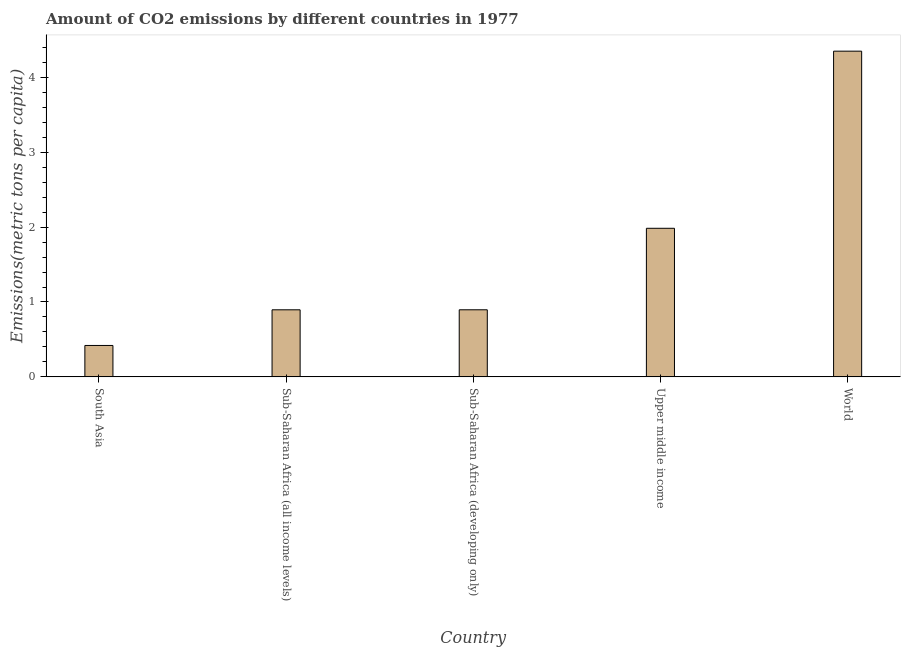Does the graph contain any zero values?
Offer a terse response. No. Does the graph contain grids?
Make the answer very short. No. What is the title of the graph?
Your answer should be very brief. Amount of CO2 emissions by different countries in 1977. What is the label or title of the Y-axis?
Offer a terse response. Emissions(metric tons per capita). What is the amount of co2 emissions in Sub-Saharan Africa (all income levels)?
Offer a very short reply. 0.9. Across all countries, what is the maximum amount of co2 emissions?
Ensure brevity in your answer.  4.35. Across all countries, what is the minimum amount of co2 emissions?
Offer a very short reply. 0.42. What is the sum of the amount of co2 emissions?
Give a very brief answer. 8.54. What is the difference between the amount of co2 emissions in Sub-Saharan Africa (all income levels) and Upper middle income?
Give a very brief answer. -1.09. What is the average amount of co2 emissions per country?
Your answer should be very brief. 1.71. What is the median amount of co2 emissions?
Your answer should be very brief. 0.9. In how many countries, is the amount of co2 emissions greater than 3.4 metric tons per capita?
Your response must be concise. 1. What is the ratio of the amount of co2 emissions in South Asia to that in Sub-Saharan Africa (developing only)?
Provide a succinct answer. 0.47. What is the difference between the highest and the second highest amount of co2 emissions?
Your answer should be very brief. 2.37. Is the sum of the amount of co2 emissions in Upper middle income and World greater than the maximum amount of co2 emissions across all countries?
Keep it short and to the point. Yes. What is the difference between the highest and the lowest amount of co2 emissions?
Your response must be concise. 3.93. How many bars are there?
Offer a very short reply. 5. Are all the bars in the graph horizontal?
Ensure brevity in your answer.  No. How many countries are there in the graph?
Offer a very short reply. 5. What is the Emissions(metric tons per capita) of South Asia?
Give a very brief answer. 0.42. What is the Emissions(metric tons per capita) in Sub-Saharan Africa (all income levels)?
Offer a very short reply. 0.9. What is the Emissions(metric tons per capita) of Sub-Saharan Africa (developing only)?
Provide a short and direct response. 0.9. What is the Emissions(metric tons per capita) in Upper middle income?
Ensure brevity in your answer.  1.98. What is the Emissions(metric tons per capita) of World?
Offer a very short reply. 4.35. What is the difference between the Emissions(metric tons per capita) in South Asia and Sub-Saharan Africa (all income levels)?
Your answer should be compact. -0.48. What is the difference between the Emissions(metric tons per capita) in South Asia and Sub-Saharan Africa (developing only)?
Give a very brief answer. -0.48. What is the difference between the Emissions(metric tons per capita) in South Asia and Upper middle income?
Provide a short and direct response. -1.56. What is the difference between the Emissions(metric tons per capita) in South Asia and World?
Provide a short and direct response. -3.93. What is the difference between the Emissions(metric tons per capita) in Sub-Saharan Africa (all income levels) and Sub-Saharan Africa (developing only)?
Offer a very short reply. -0. What is the difference between the Emissions(metric tons per capita) in Sub-Saharan Africa (all income levels) and Upper middle income?
Your response must be concise. -1.09. What is the difference between the Emissions(metric tons per capita) in Sub-Saharan Africa (all income levels) and World?
Offer a very short reply. -3.45. What is the difference between the Emissions(metric tons per capita) in Sub-Saharan Africa (developing only) and Upper middle income?
Make the answer very short. -1.09. What is the difference between the Emissions(metric tons per capita) in Sub-Saharan Africa (developing only) and World?
Offer a very short reply. -3.45. What is the difference between the Emissions(metric tons per capita) in Upper middle income and World?
Provide a succinct answer. -2.37. What is the ratio of the Emissions(metric tons per capita) in South Asia to that in Sub-Saharan Africa (all income levels)?
Ensure brevity in your answer.  0.47. What is the ratio of the Emissions(metric tons per capita) in South Asia to that in Sub-Saharan Africa (developing only)?
Your answer should be compact. 0.47. What is the ratio of the Emissions(metric tons per capita) in South Asia to that in Upper middle income?
Provide a short and direct response. 0.21. What is the ratio of the Emissions(metric tons per capita) in South Asia to that in World?
Your answer should be compact. 0.1. What is the ratio of the Emissions(metric tons per capita) in Sub-Saharan Africa (all income levels) to that in Sub-Saharan Africa (developing only)?
Provide a succinct answer. 1. What is the ratio of the Emissions(metric tons per capita) in Sub-Saharan Africa (all income levels) to that in Upper middle income?
Keep it short and to the point. 0.45. What is the ratio of the Emissions(metric tons per capita) in Sub-Saharan Africa (all income levels) to that in World?
Provide a succinct answer. 0.21. What is the ratio of the Emissions(metric tons per capita) in Sub-Saharan Africa (developing only) to that in Upper middle income?
Keep it short and to the point. 0.45. What is the ratio of the Emissions(metric tons per capita) in Sub-Saharan Africa (developing only) to that in World?
Your response must be concise. 0.21. What is the ratio of the Emissions(metric tons per capita) in Upper middle income to that in World?
Your response must be concise. 0.46. 